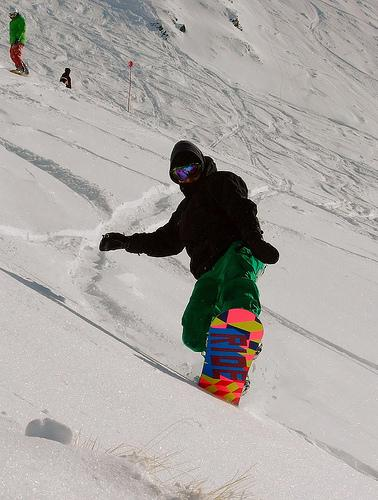Question: who has the snowboard closest to the camera?
Choices:
A. The girl in the red hat.
B. The lady with the purple pants.
C. The man with the black coat.
D. The boy with the helmet.
Answer with the letter. Answer: C Question: where is this photo taken from?
Choices:
A. A snowy mountain.
B. A ski lodge.
C. Near a fireplace.
D. On a ski lift.
Answer with the letter. Answer: A Question: why is this person in the snow?
Choices:
A. Making a snow fort.
B. Making a snow angel.
C. He is sledding.
D. He is snowboarding.
Answer with the letter. Answer: D Question: what time of year is it?
Choices:
A. Spring.
B. Fall.
C. Winter.
D. Summer.
Answer with the letter. Answer: C 